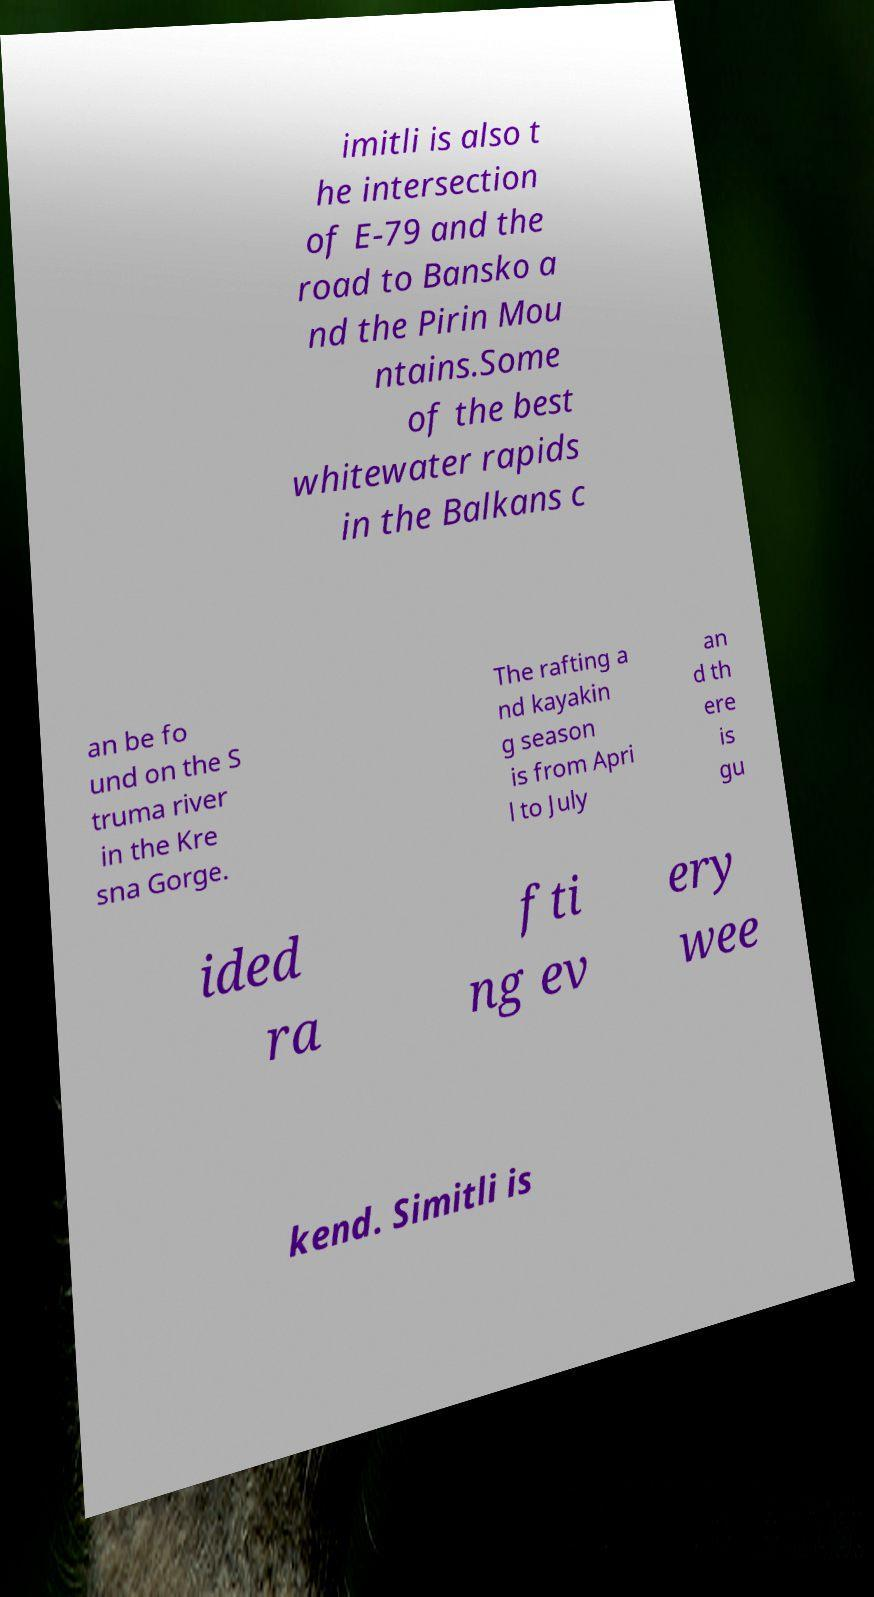I need the written content from this picture converted into text. Can you do that? imitli is also t he intersection of E-79 and the road to Bansko a nd the Pirin Mou ntains.Some of the best whitewater rapids in the Balkans c an be fo und on the S truma river in the Kre sna Gorge. The rafting a nd kayakin g season is from Apri l to July an d th ere is gu ided ra fti ng ev ery wee kend. Simitli is 